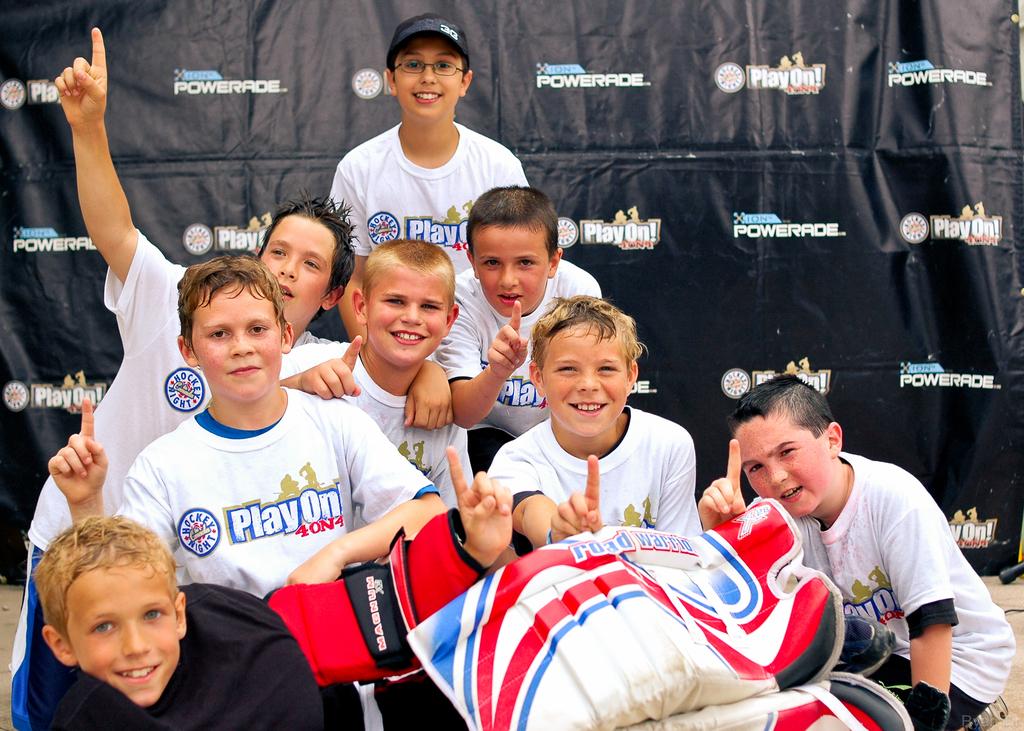Is playon a children's sport group?
Ensure brevity in your answer.  Yes. Is powerade a sponsor?
Offer a terse response. Yes. 